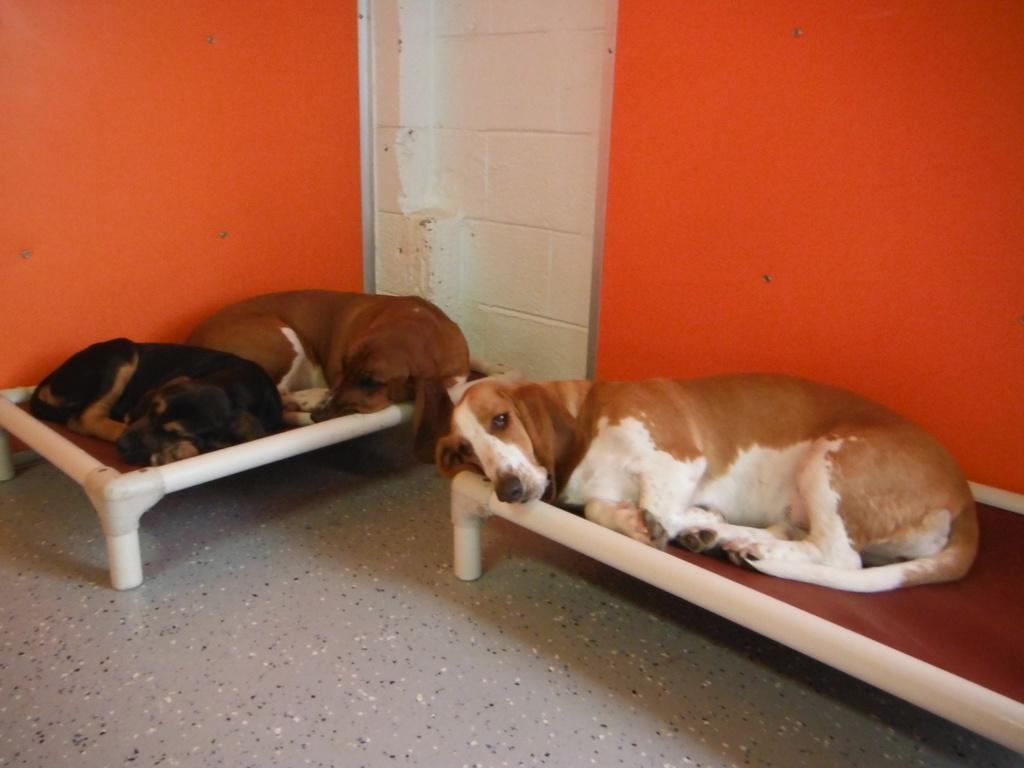How would you summarize this image in a sentence or two? In this picture there are three dogs sleeping on an object and the background wall is in orange and white color. 